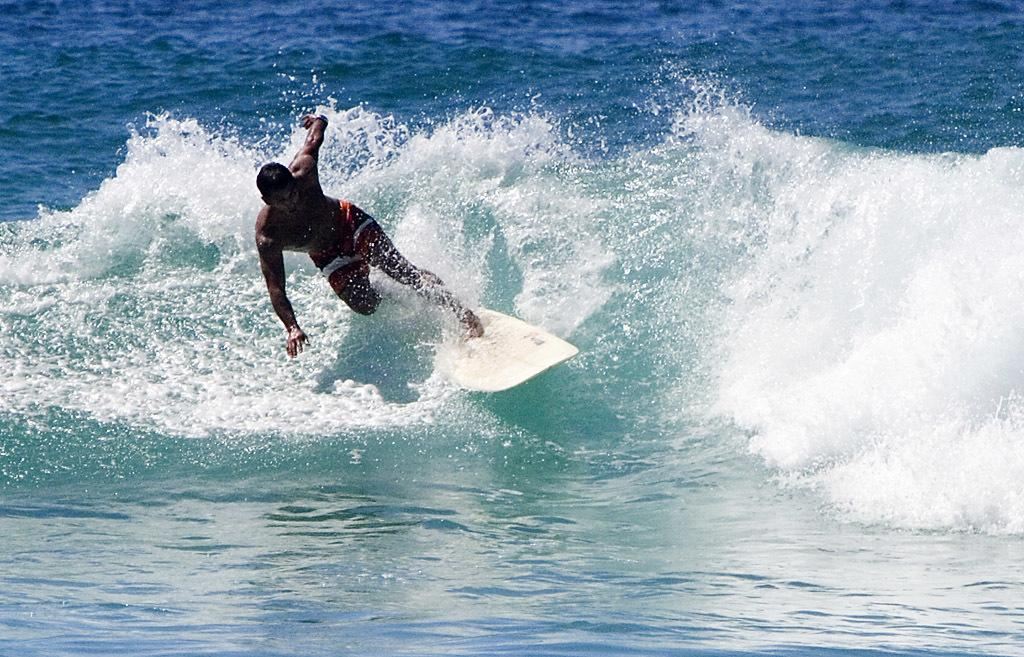Who is the main subject in the image? There is a man in the image. What is the man doing in the image? The man is surfing in the water. How is the man surfing in the water? The man is standing on a surfboard. What type of ear is visible on the surfboard in the image? There is no ear visible on the surfboard in the image. Is the man experiencing any trouble while surfing in the image? The image does not provide any information about the man's experience while surfing, so it cannot be determined if he is experiencing trouble. 